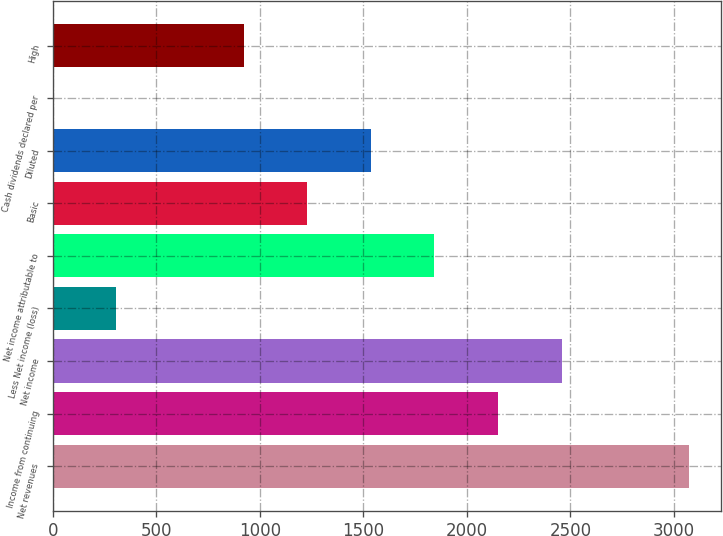Convert chart to OTSL. <chart><loc_0><loc_0><loc_500><loc_500><bar_chart><fcel>Net revenues<fcel>Income from continuing<fcel>Net income<fcel>Less Net income (loss)<fcel>Net income attributable to<fcel>Basic<fcel>Diluted<fcel>Cash dividends declared per<fcel>High<nl><fcel>3072<fcel>2150.56<fcel>2457.7<fcel>307.72<fcel>1843.42<fcel>1229.14<fcel>1536.28<fcel>0.58<fcel>922<nl></chart> 